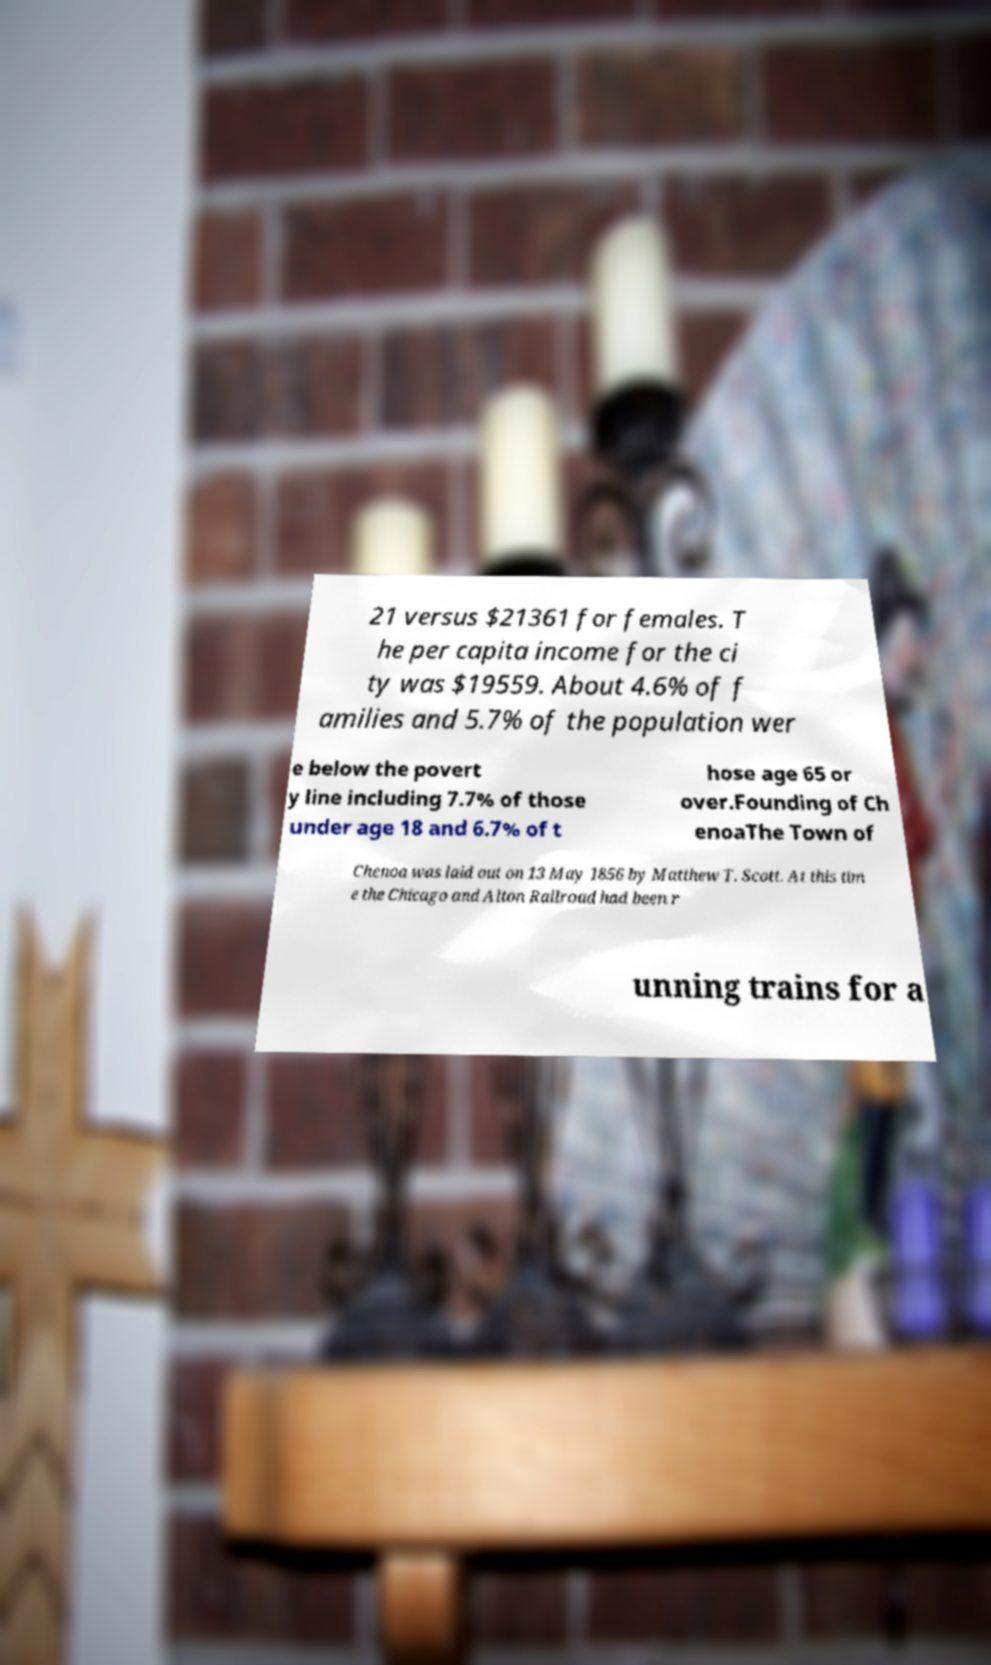Could you assist in decoding the text presented in this image and type it out clearly? 21 versus $21361 for females. T he per capita income for the ci ty was $19559. About 4.6% of f amilies and 5.7% of the population wer e below the povert y line including 7.7% of those under age 18 and 6.7% of t hose age 65 or over.Founding of Ch enoaThe Town of Chenoa was laid out on 13 May 1856 by Matthew T. Scott. At this tim e the Chicago and Alton Railroad had been r unning trains for a 